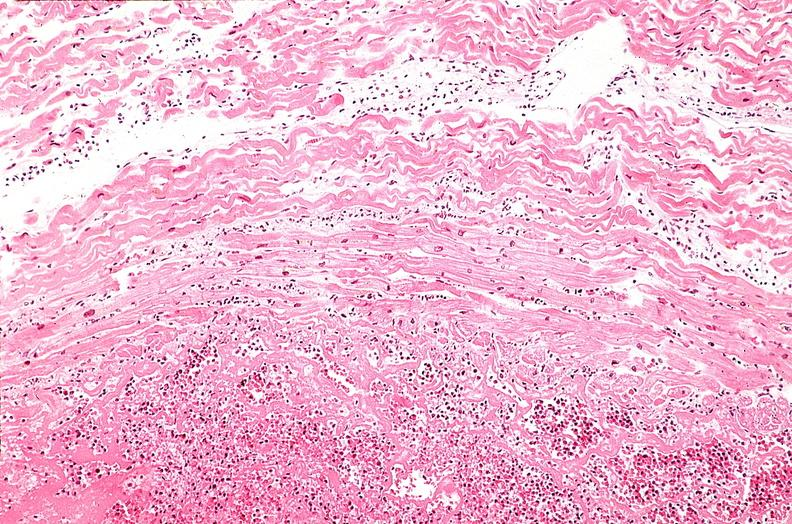s carcinomatosis endometrium primary present?
Answer the question using a single word or phrase. No 